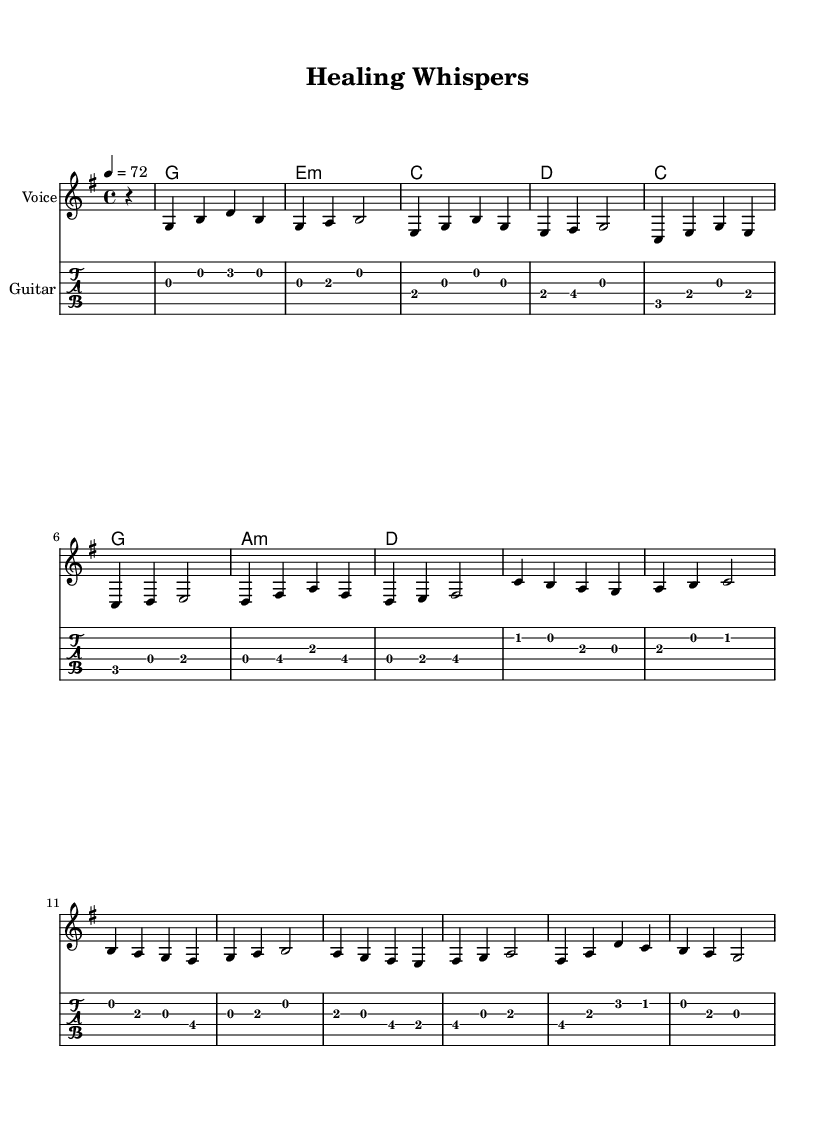What is the key signature of this music? The key signature is G major, which has one sharp (F#). This can be determined by looking at the key signature indicated at the beginning of the sheet music, where there’s a sharp symbol representing the note F# and no other accidentals are present.
Answer: G major What is the time signature of this music? The time signature is 4/4, which is indicated at the beginning of the sheet music. In a 4/4 time signature, there are four beats in each measure, and the quarter note gets one beat. This can be inferred directly from the notation following the introductory information.
Answer: 4/4 What is the tempo marking in this piece? The tempo marking is 72, indicated by the metronome marking (4 = 72) at the beginning of the score. This means the piece should be played at 72 beats per minute, where the quarter note receives one beat.
Answer: 72 How many measures are in the melody? The melody consists of 16 measures, which can be counted by identifying the vertical bar lines that separate each measure. Each section of notes between two bar lines represents a single measure, and when counted gives the total.
Answer: 16 What is the first chord in the harmony? The first chord in the harmony is G major, indicated by the chord notation preceding the melody line. This can be noticed as the very first entry in the harmonic section, where it clearly states "g1" for the G major chord.
Answer: G What is the half note's location in the melody? There are no half notes present in the melody; the piece exclusively features quarter and whole notes. This determination is made by analyzing the rhythmic values of the notes throughout the melody line, confirming that there are no half notes indicated.
Answer: None What kind of song is "Healing Whispers"? "Healing Whispers" is classified as a soothing acoustic pop ballad, marked by its gentle melody and harmonic structure aimed at relaxation and stress relief. This classification can be inferred from the title and the style of music typically associated with the characteristics of pop ballads.
Answer: Soothing acoustic pop ballad 